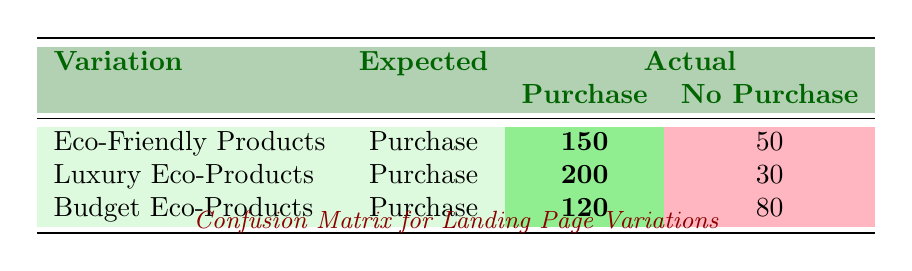What is the count of actual conversions for the "Eco-Friendly Products" variation? The table shows that for the "Eco-Friendly Products" variation, there are 150 actual conversions (Purchases) and 50 non-conversions (No Purchase). The count of actual conversions is therefore the count for Purchase, which is 150.
Answer: 150 How many people did not purchase from the "Budget Eco-Products" landing page variation? The table indicates that for the "Budget Eco-Products" variation, there were 80 actual conversions marked as No Purchase. Hence, the number of people who did not purchase is 80.
Answer: 80 What is the total count of purchases across all landing page variations? To find the total purchases, we sum the counts of actual conversions for all variations: 150 (Eco-Friendly Products) + 200 (Luxury Eco-Products) + 120 (Budget Eco-Products) = 470.
Answer: 470 Did more people actually purchase from "Luxury Eco-Products" than from "Eco-Friendly Products"? The table indicates that 200 people purchased from "Luxury Eco-Products" while 150 purchased from "Eco-Friendly Products." Therefore, more people purchased from Luxury Eco-Products.
Answer: Yes What is the difference in the number of people who purchased from "Luxury Eco-Products" and "Budget Eco-Products"? The actual conversions for "Luxury Eco-Products" is 200 and for "Budget Eco-Products" is 120. The difference is calculated as 200 - 120 = 80.
Answer: 80 Which variation has the highest number of non-purchases? The table shows the non-purchases: Eco-Friendly Products has 50, Luxury Eco-Products has 30, and Budget Eco-Products has 80. Therefore, the variation with the highest number of non-purchases is "Budget Eco-Products."
Answer: Budget Eco-Products What is the average number of purchases across all variations? To find the average, we add the purchases: 150 + 200 + 120 = 470. There are three variations, so we divide by 3: 470 / 3 = approximately 156.67.
Answer: 156.67 Is it true that the "Eco-Friendly Products" variation had more actual purchases than actual non-purchases? The table indicates 150 actual purchases and 50 actual non-purchases for "Eco-Friendly Products." Since 150 is greater than 50, the statement is true.
Answer: Yes What is the total number of expected purchases that resulted in no purchases across all variations? The expected purchases are all labeled as Purchase, so we check the counts for Non Purchase: 50 (Eco-Friendly Products) + 30 (Luxury Eco-Products) + 80 (Budget Eco-Products) = 160.
Answer: 160 